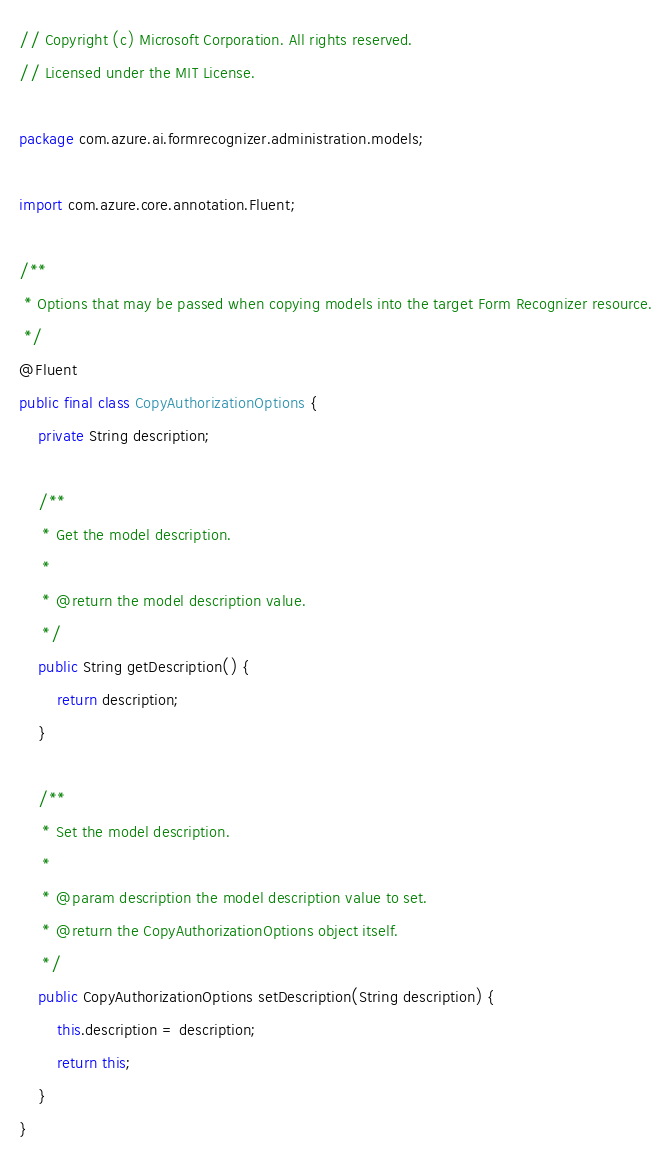<code> <loc_0><loc_0><loc_500><loc_500><_Java_>// Copyright (c) Microsoft Corporation. All rights reserved.
// Licensed under the MIT License.

package com.azure.ai.formrecognizer.administration.models;

import com.azure.core.annotation.Fluent;

/**
 * Options that may be passed when copying models into the target Form Recognizer resource.
 */
@Fluent
public final class CopyAuthorizationOptions {
    private String description;

    /**
     * Get the model description.
     *
     * @return the model description value.
     */
    public String getDescription() {
        return description;
    }

    /**
     * Set the model description.
     *
     * @param description the model description value to set.
     * @return the CopyAuthorizationOptions object itself.
     */
    public CopyAuthorizationOptions setDescription(String description) {
        this.description = description;
        return this;
    }
}
</code> 